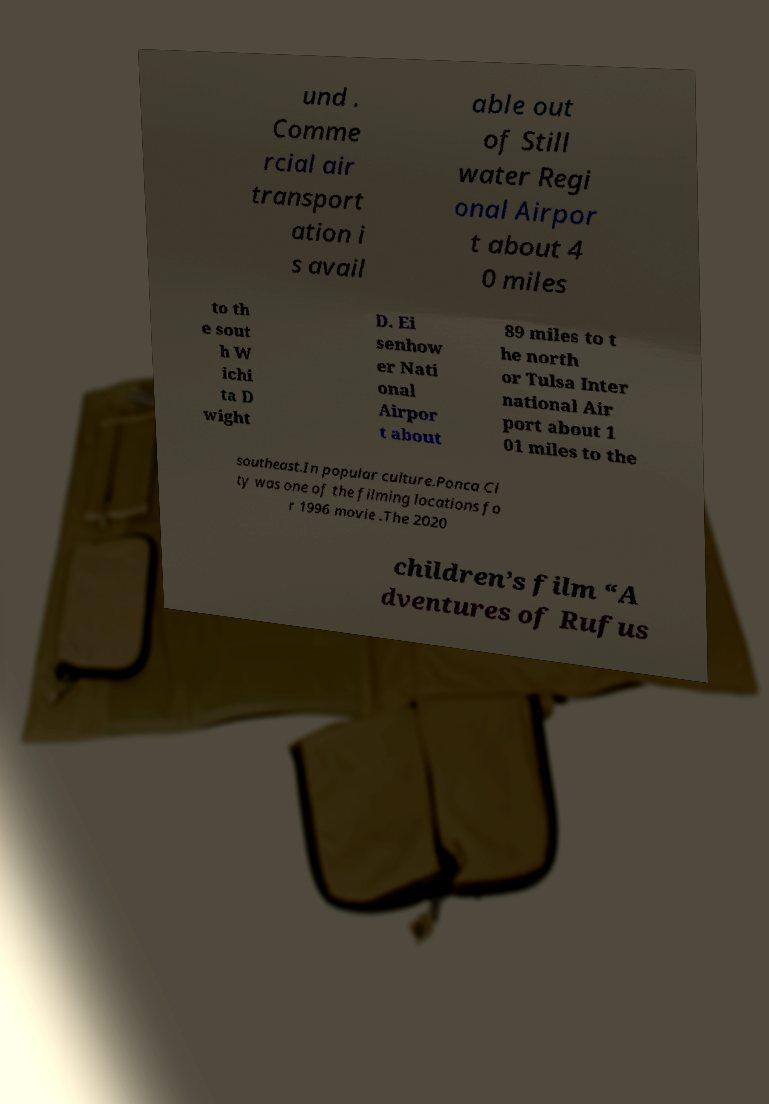Could you assist in decoding the text presented in this image and type it out clearly? und . Comme rcial air transport ation i s avail able out of Still water Regi onal Airpor t about 4 0 miles to th e sout h W ichi ta D wight D. Ei senhow er Nati onal Airpor t about 89 miles to t he north or Tulsa Inter national Air port about 1 01 miles to the southeast.In popular culture.Ponca Ci ty was one of the filming locations fo r 1996 movie .The 2020 children’s film “A dventures of Rufus 